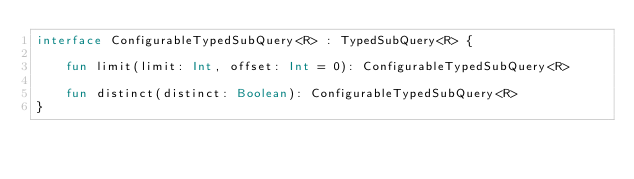<code> <loc_0><loc_0><loc_500><loc_500><_Kotlin_>interface ConfigurableTypedSubQuery<R> : TypedSubQuery<R> {

    fun limit(limit: Int, offset: Int = 0): ConfigurableTypedSubQuery<R>

    fun distinct(distinct: Boolean): ConfigurableTypedSubQuery<R>
}</code> 